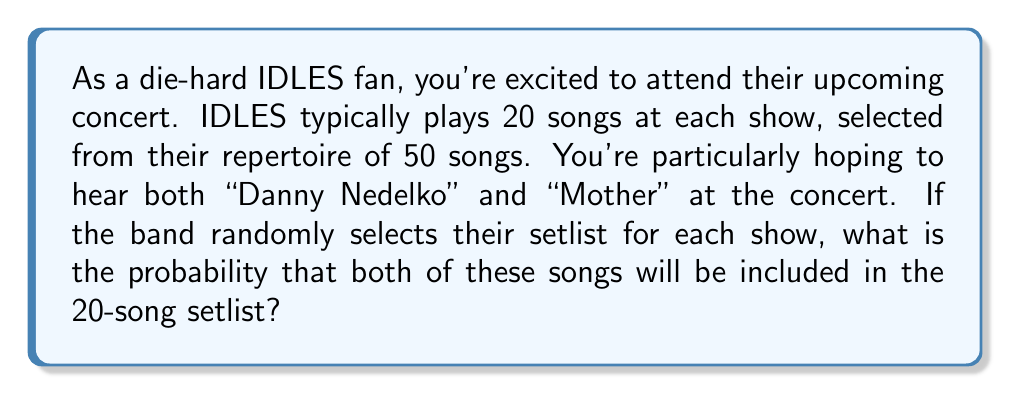Give your solution to this math problem. Let's approach this step-by-step:

1) First, we need to calculate the total number of possible 20-song setlists that can be created from 50 songs. This is a combination problem, represented as:

   $$\binom{50}{20} = \frac{50!}{20!(50-20)!} = \frac{50!}{20!30!}$$

2) Now, we need to calculate the number of setlists that include both "Danny Nedelko" and "Mother". To do this, we can:
   - Include these 2 songs in the setlist
   - Choose the remaining 18 songs from the other 48 songs

   This can be represented as:

   $$\binom{48}{18} = \frac{48!}{18!(48-18)!} = \frac{48!}{18!30!}$$

3) The probability is the number of favorable outcomes divided by the total number of possible outcomes:

   $$P(\text{both songs}) = \frac{\binom{48}{18}}{\binom{50}{20}}$$

4) Let's calculate this:

   $$P(\text{both songs}) = \frac{\frac{48!}{18!30!}}{\frac{50!}{20!30!}}$$

5) The 30! cancels out in the numerator and denominator:

   $$P(\text{both songs}) = \frac{48! \cdot 20!}{50! \cdot 18!}$$

6) Calculating this gives us:

   $$P(\text{both songs}) \approx 0.1556$$
Answer: The probability of hearing both "Danny Nedelko" and "Mother" at a random IDLES concert with a 20-song setlist is approximately 0.1556 or 15.56%. 